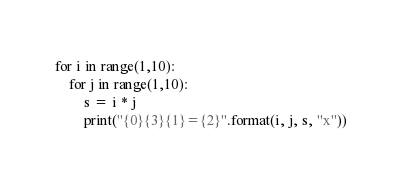<code> <loc_0><loc_0><loc_500><loc_500><_Python_>for i in range(1,10):
    for j in range(1,10):
        s = i * j
        print("{0}{3}{1}={2}".format(i, j, s, "x"))</code> 